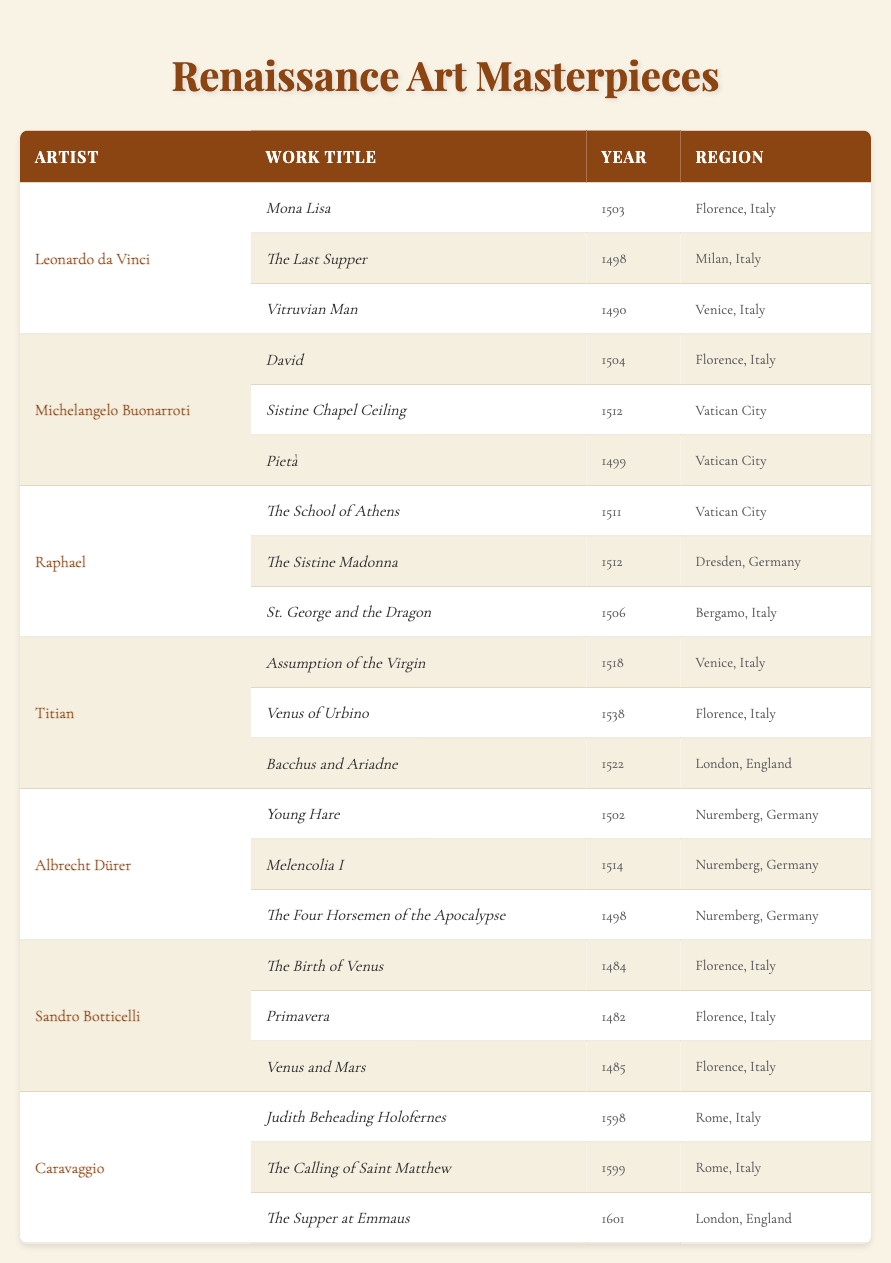What are the notable works of Leonardo da Vinci? Leonardo da Vinci has three notable works listed in the table: "Mona Lisa," "The Last Supper," and "Vitruvian Man."
Answer: "Mona Lisa," "The Last Supper," "Vitruvian Man" How many notable works did Michelangelo create? The table shows that Michelangelo created three notable works: "David," "Sistine Chapel Ceiling," and "Pietà."
Answer: 3 Which work by Titian was created in London? The table indicates that "Bacchus and Ariadne" was created by Titian in London.
Answer: "Bacchus and Ariadne" Which artist is associated with the work "Judith Beheading Holofernes"? The artist associated with "Judith Beheading Holofernes" is Caravaggio, as per the data in the table.
Answer: Caravaggio Was "The Birth of Venus" painted in Florence, Italy? Yes, according to the table, "The Birth of Venus" was indeed painted in Florence, Italy, by Sandro Botticelli.
Answer: Yes What is the earliest year listed for a work by Albrecht Dürer? The table lists "The Four Horsemen of the Apocalypse," created in 1498, as the earliest work by Albrecht Dürer.
Answer: 1498 Which region has the most notable works by Botticelli? The table shows that all of Botticelli's notable works ("The Birth of Venus," "Primavera," and "Venus and Mars") were created in Florence, indicating it has the most works by him.
Answer: Florence, Italy List the notable works created in Vatican City. The notable works created in Vatican City, according to the table, are "Sistine Chapel Ceiling" and "Pietà" by Michelangelo, and "The School of Athens" by Raphael.
Answer: "Sistine Chapel Ceiling," "Pietà," "The School of Athens" Who created works in both Florence and Rome? The table shows that both Titian (with "Venus of Urbino" in Florence) and Caravaggio (with "Judith Beheading Holofernes" in Rome) created works in those regions.
Answer: Titian and Caravaggio Calculate the total number of notable works for artists from Germany listed in the table. Albrecht Dürer has three notable works listed from Nuremberg. Raphael has one work in Dresden. Therefore, the total from Germany is 3 (Dürer) + 1 (Raphael) = 4.
Answer: 4 Which artist has the latest work listed in the table, and what is its title? The latest work listed is "The Supper at Emmaus" by Caravaggio, created in 1601.
Answer: Caravaggio, "The Supper at Emmaus" Are there more works attributed to Italian artists than to German artists? Yes, if we count the Italian artists (Leonardo da Vinci, Michelangelo, Raphael, Titian, Botticelli, Caravaggio) and their notable works, we find a total of 16, while there are 3 for German artists (Dürer has 3, and Raphael has 1 in Germany).
Answer: Yes Which artist created works primarily in the 16th century? Leonardo da Vinci, Michelangelo Buonarroti, Titian, and Raphael all created notable works primarily in the 16th century (from 1500 to 1599).
Answer: Leonardo da Vinci, Michelangelo, Titian, Raphael Identify the artist with works that span multiple regions. Titian created works in both Venice and Florence, as well as in London.
Answer: Titian 